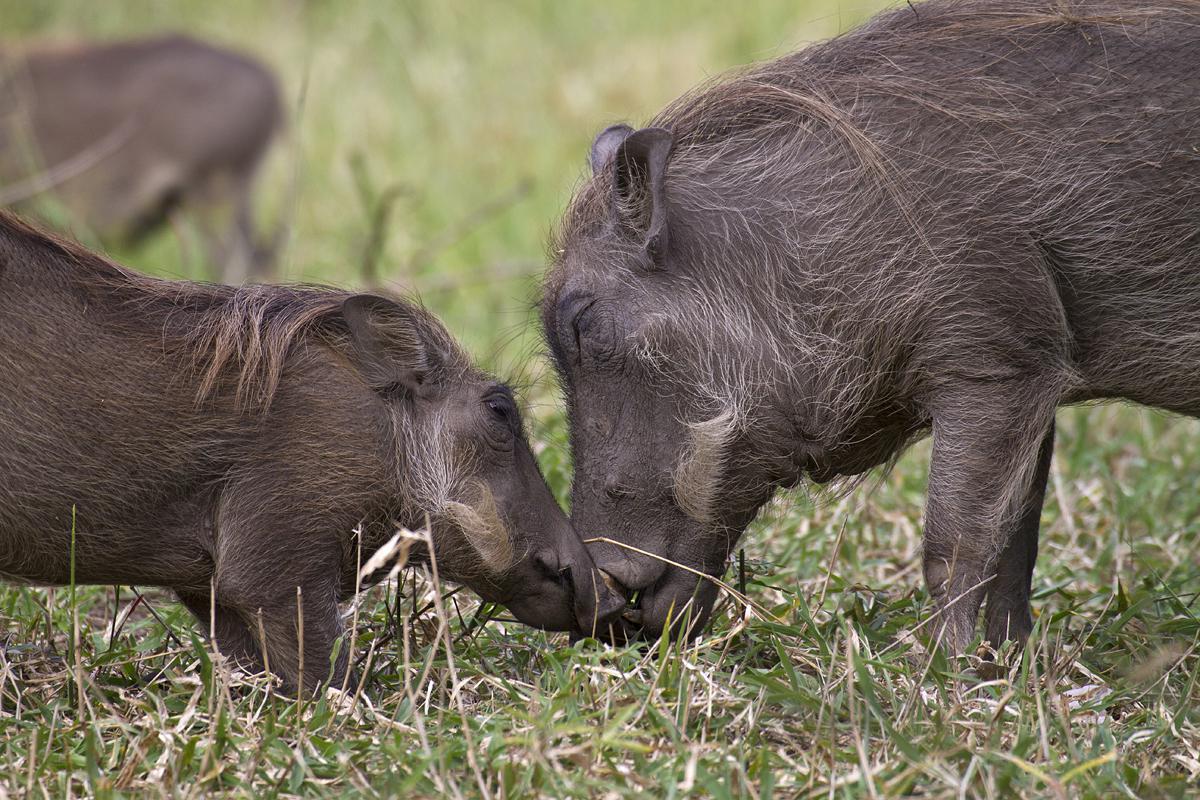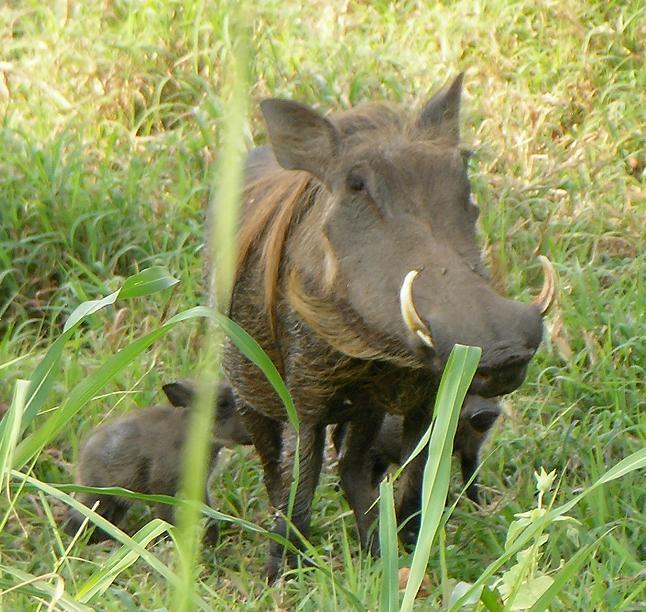The first image is the image on the left, the second image is the image on the right. Given the left and right images, does the statement "Baby warthogs are standing close to their mother." hold true? Answer yes or no. Yes. The first image is the image on the left, the second image is the image on the right. Analyze the images presented: Is the assertion "An image shows one adult warthog near two small young warthogs." valid? Answer yes or no. Yes. 